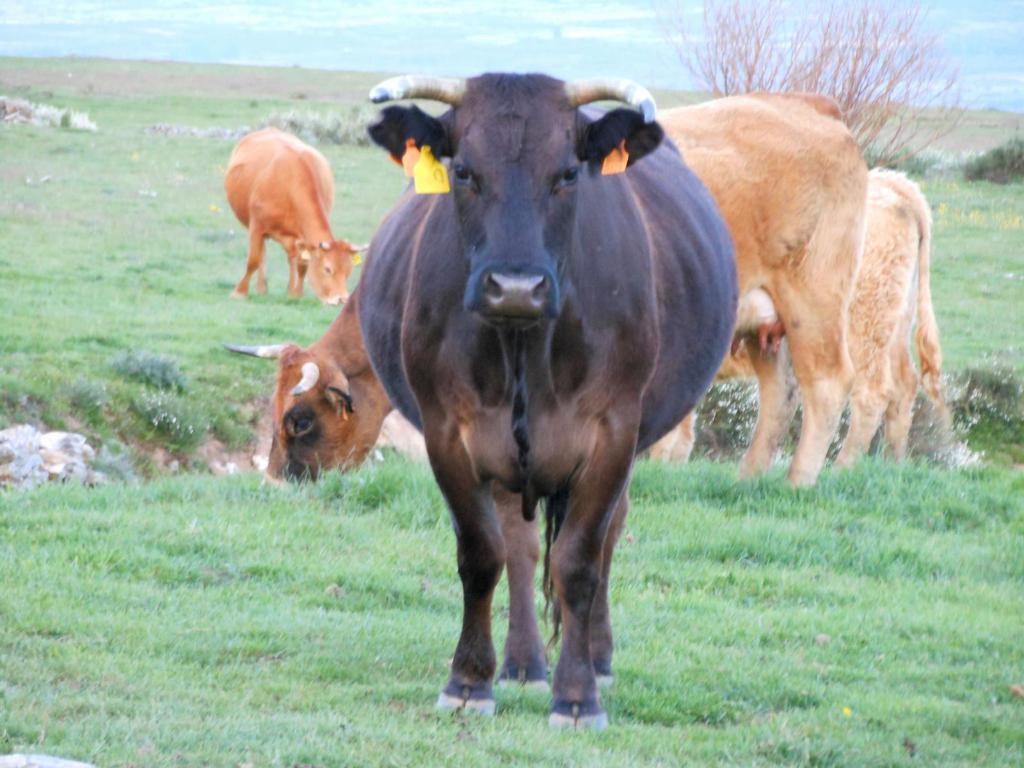How would you summarize this image in a sentence or two? There is a black cow on the grasses. In the back there are cows grazing on the grasses. In the background there is sky and tree. 